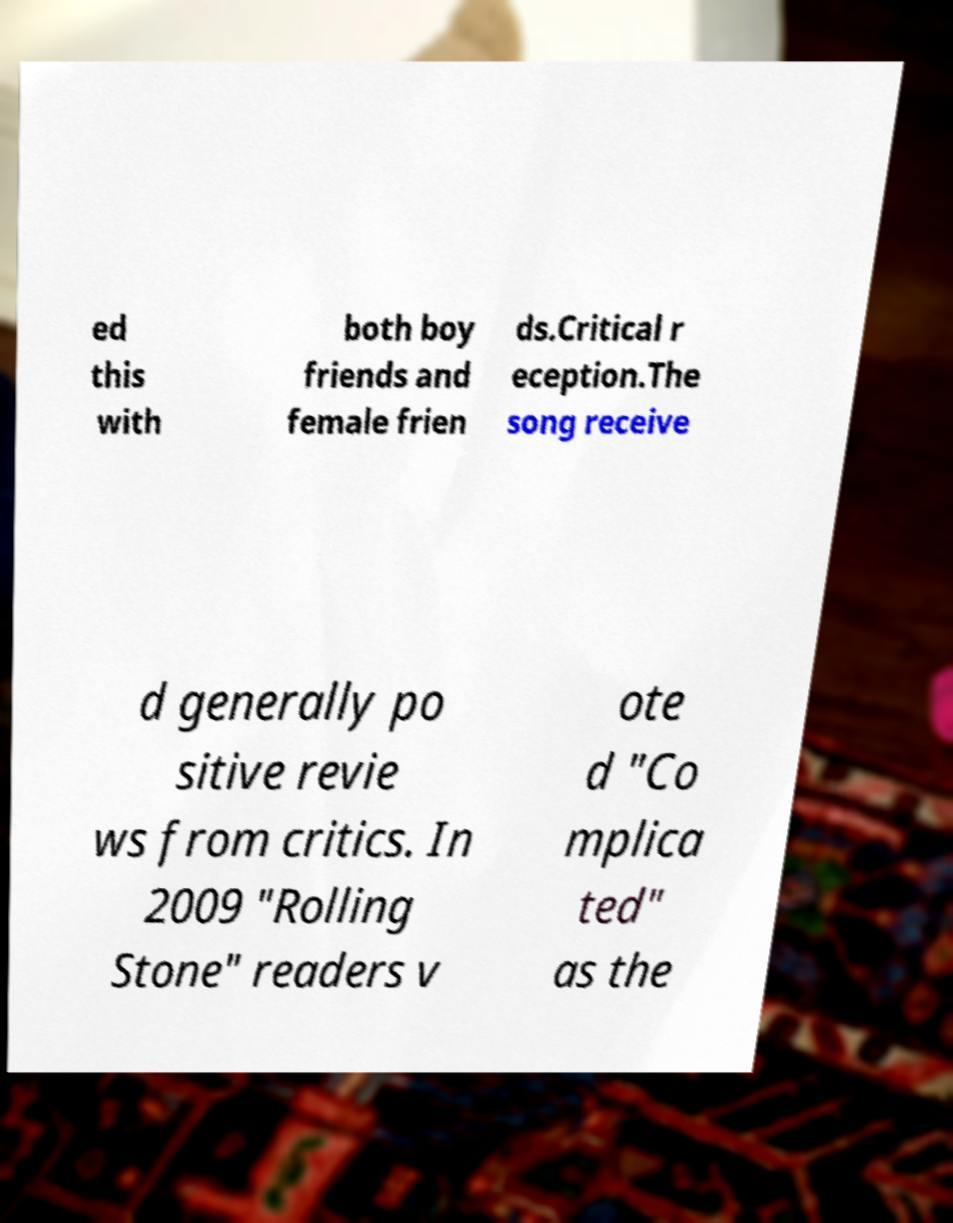Please read and relay the text visible in this image. What does it say? ed this with both boy friends and female frien ds.Critical r eception.The song receive d generally po sitive revie ws from critics. In 2009 "Rolling Stone" readers v ote d "Co mplica ted" as the 